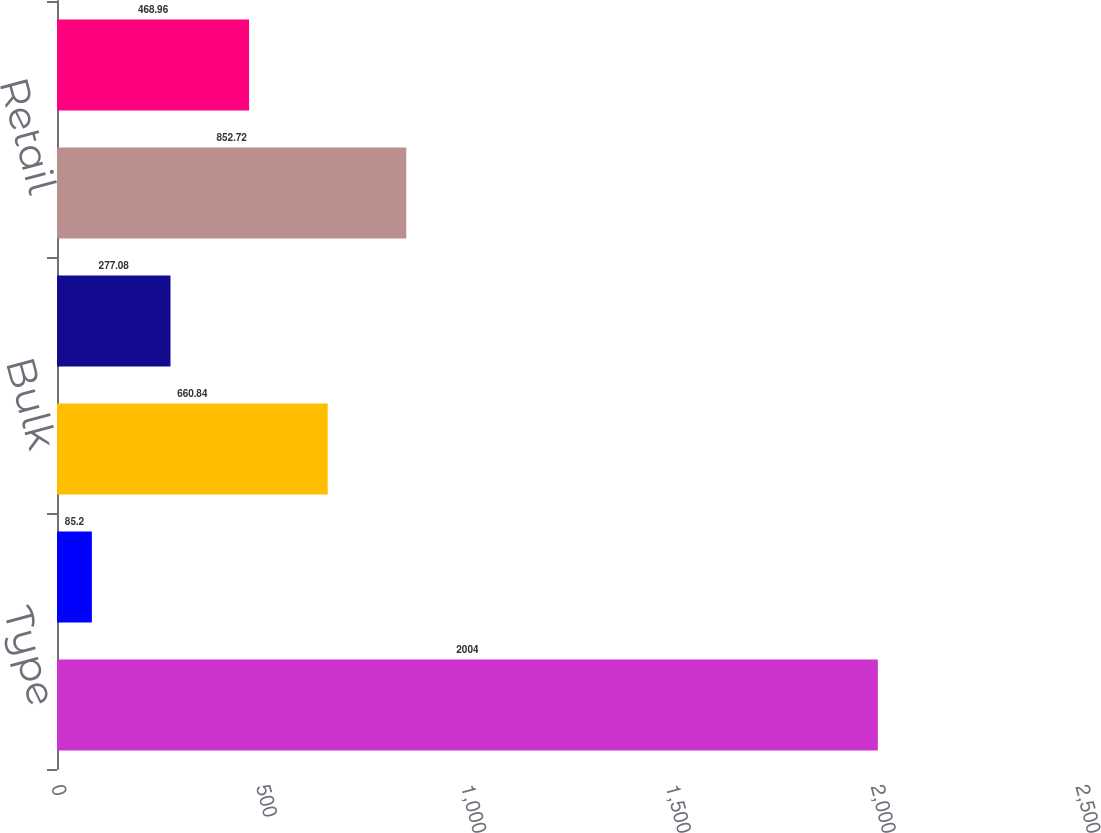Convert chart. <chart><loc_0><loc_0><loc_500><loc_500><bar_chart><fcel>Type<fcel>Service Centers<fcel>Bulk<fcel>Office<fcel>Retail<fcel>Total<nl><fcel>2004<fcel>85.2<fcel>660.84<fcel>277.08<fcel>852.72<fcel>468.96<nl></chart> 